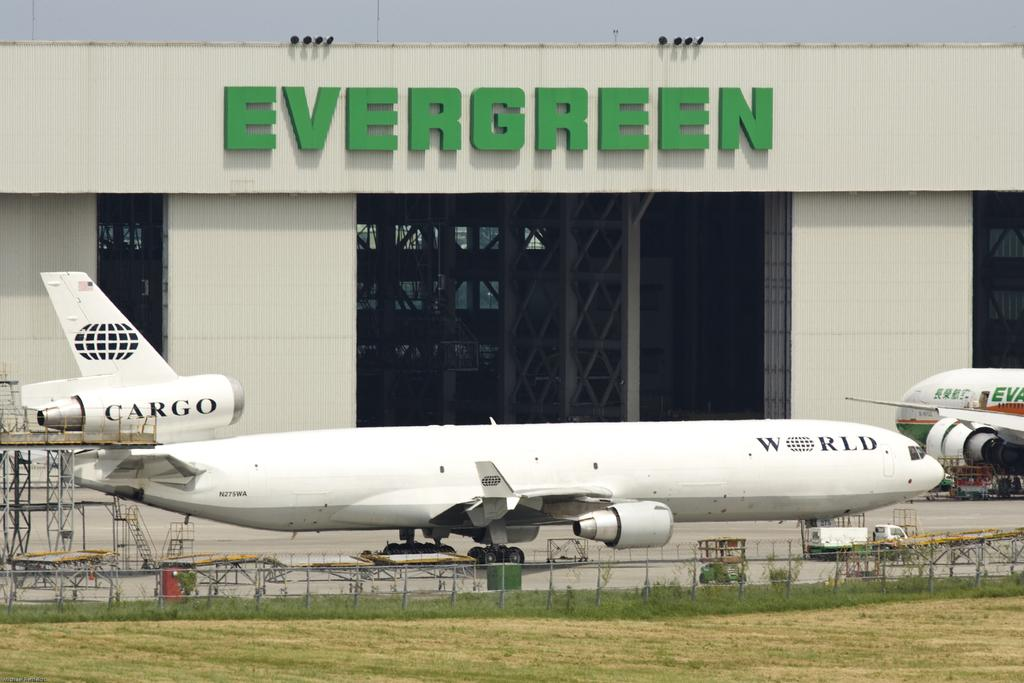What type of structure is visible in the image? There is a building in the image. What can be seen on the building? The building has text on it and a grille. What is located in front of the building? There are airplanes on the ground, a fence, stairs, and grass in front of the building. What is visible in the background of the image? The sky is visible in the image. What channel is the building located on in the image? There is no channel present in the image; it is a physical building. Can you tell me about the history of the coastline in the image? There is no coastline present in the image; it features a building with airplanes, a fence, stairs, grass, and the sky visible in the background. 